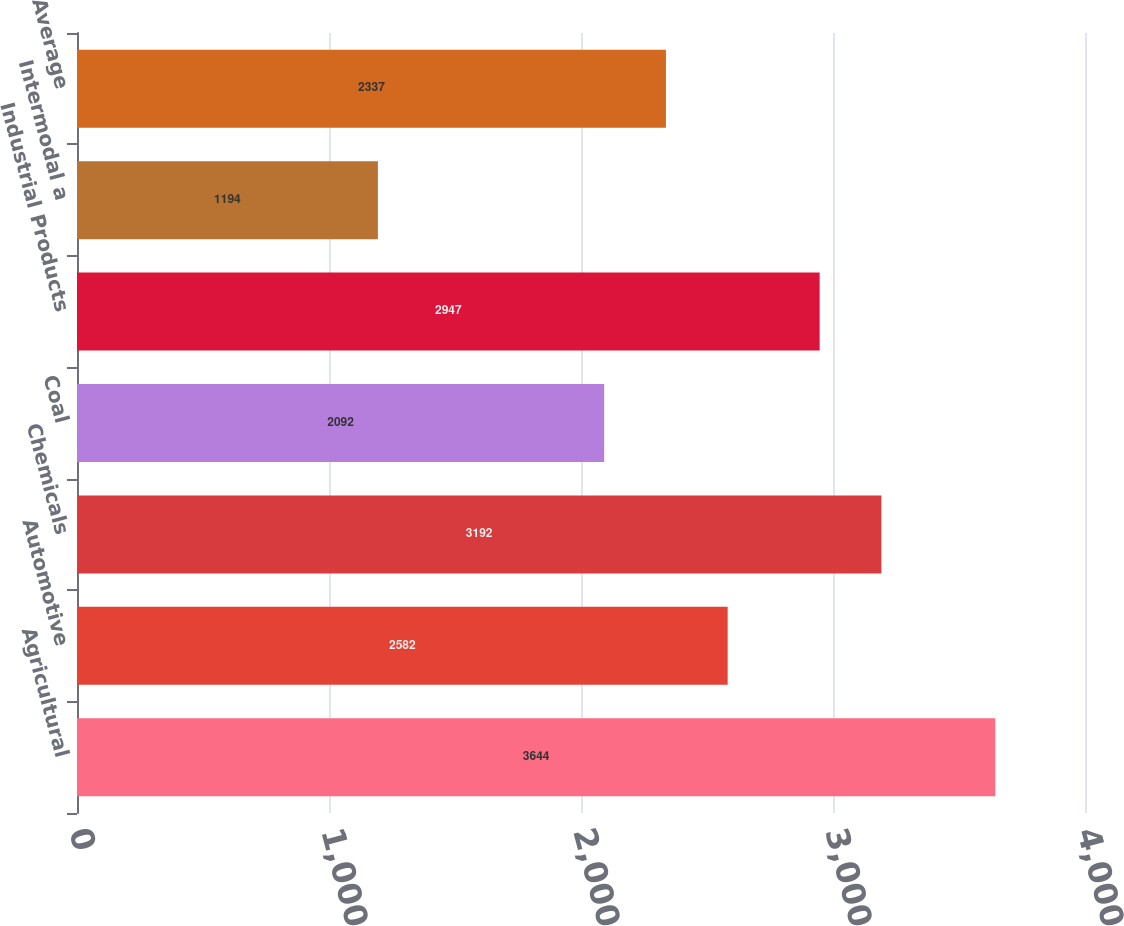Convert chart to OTSL. <chart><loc_0><loc_0><loc_500><loc_500><bar_chart><fcel>Agricultural<fcel>Automotive<fcel>Chemicals<fcel>Coal<fcel>Industrial Products<fcel>Intermodal a<fcel>Average<nl><fcel>3644<fcel>2582<fcel>3192<fcel>2092<fcel>2947<fcel>1194<fcel>2337<nl></chart> 